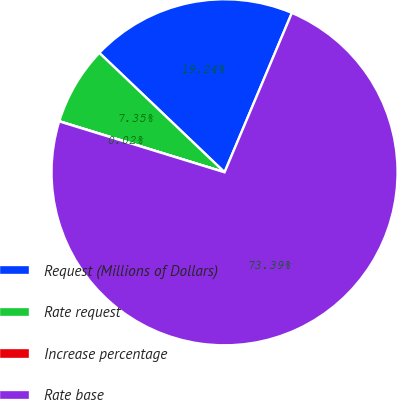Convert chart. <chart><loc_0><loc_0><loc_500><loc_500><pie_chart><fcel>Request (Millions of Dollars)<fcel>Rate request<fcel>Increase percentage<fcel>Rate base<nl><fcel>19.24%<fcel>7.35%<fcel>0.02%<fcel>73.39%<nl></chart> 